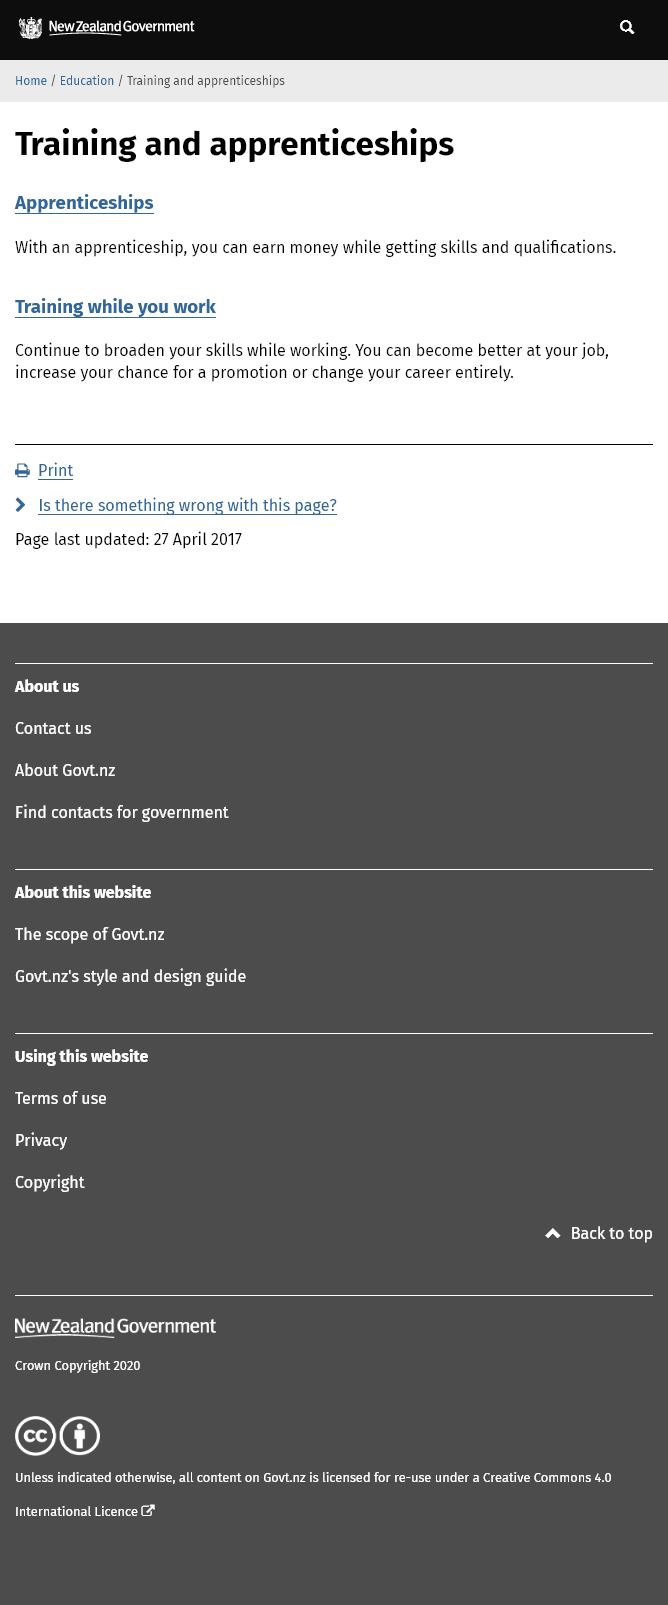Specify some key components in this picture. Yes, training can increase your chances of a promotion by enabling you to become better at your job, increase your likelihood of promotion, or even change your career entirely. Yes, it is possible to earn a wage while pursuing an apprenticeship and acquiring skills and qualifications. Yes, it is possible to train and broaden your skills while working. 